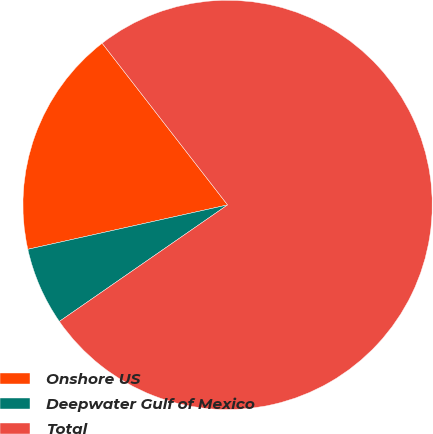Convert chart. <chart><loc_0><loc_0><loc_500><loc_500><pie_chart><fcel>Onshore US<fcel>Deepwater Gulf of Mexico<fcel>Total<nl><fcel>17.98%<fcel>6.16%<fcel>75.86%<nl></chart> 